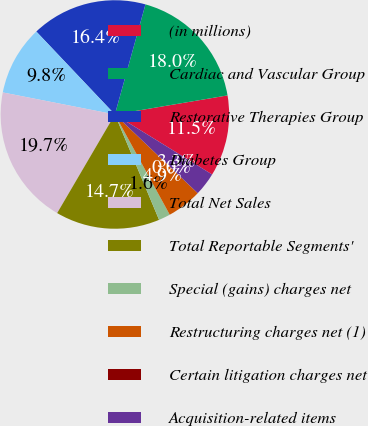Convert chart to OTSL. <chart><loc_0><loc_0><loc_500><loc_500><pie_chart><fcel>(in millions)<fcel>Cardiac and Vascular Group<fcel>Restorative Therapies Group<fcel>Diabetes Group<fcel>Total Net Sales<fcel>Total Reportable Segments'<fcel>Special (gains) charges net<fcel>Restructuring charges net (1)<fcel>Certain litigation charges net<fcel>Acquisition-related items<nl><fcel>11.47%<fcel>18.02%<fcel>16.38%<fcel>9.84%<fcel>19.66%<fcel>14.75%<fcel>1.65%<fcel>4.93%<fcel>0.01%<fcel>3.29%<nl></chart> 